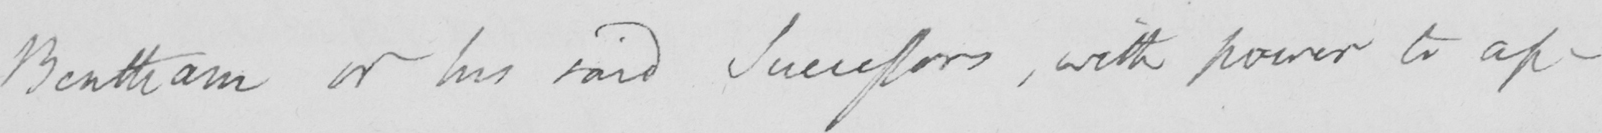Can you tell me what this handwritten text says? Bentham or his said Successors , with power to ap- 